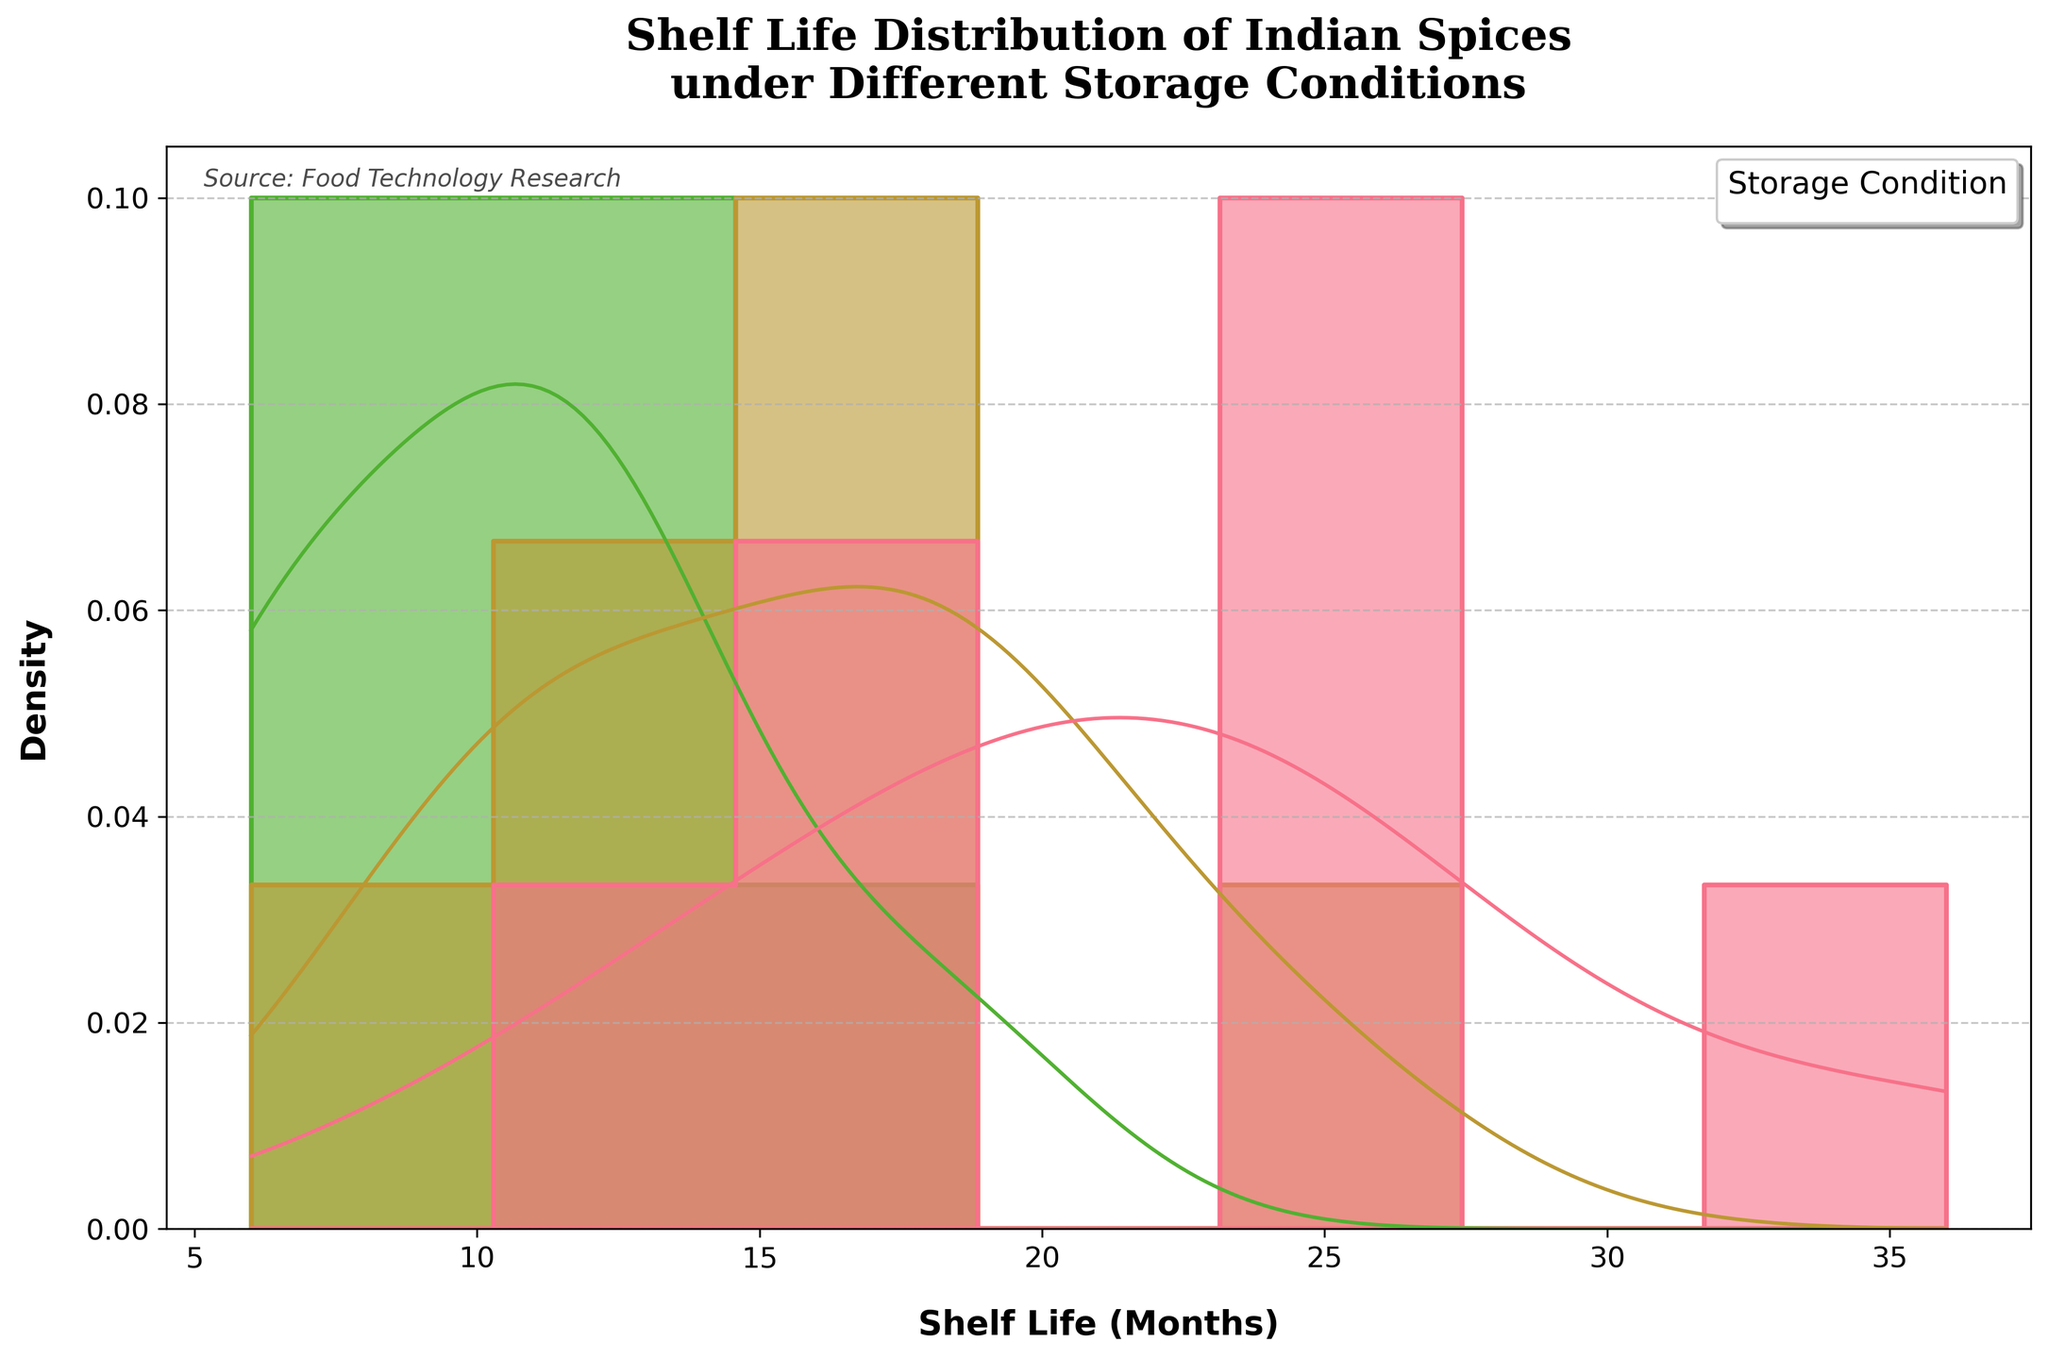what is the title of the plot? The title of the plot is usually displayed at the top center of the figure in large bold text. In this case, it reads 'Shelf Life Distribution of Indian Spices under Different Storage Conditions'.
Answer: Shelf Life Distribution of Indian Spices under Different Storage Conditions What is plotted on the x-axis, and what are the units? The x-axis represents the 'Shelf Life (Months)', which indicates the number of months the spices can be stored under different conditions.
Answer: Shelf Life (Months) Which storage condition shows the highest density for shelf life at around 24 months? To find the storage condition with the highest density around 24 months, we look at the KDE (density curve) peaks near 24 months. The Cool_Dry condition shows the highest peak around 24 months.
Answer: Cool_Dry Which spice has the shortest shelf life under Warm_Humid conditions? To determine the spice with the shortest shelf life under Warm_Humid conditions, we inspect the histogram bars corresponding to 6 months and find that Cardamom has this value.
Answer: Cardamom Does Cool_Dry storage condition consistently show higher shelf life compared to Room_Temperature and Warm_Humid conditions? To answer this, we observe the KDE (density curves) and histogram bars for Cool_Dry (usually in different colors) and see they tend to show higher shelf life months consistently compared to those for Room_Temperature and Warm_Humid.
Answer: Yes Which storage condition typically results in the lowest shelf life and by how much on average? Analyze the KDE density curves and histogram bars for elements like lowest peaks and shortest x-axis intervals. The Warm_Humid condition has the lowest shelf life, averaging around 9-12 months across different spices.
Answer: Warm_Humid by around 9-12 months On average, how much longer is the shelf life under Cool_Dry compared to Warm_Humid conditions? Calculate the average shelf life for spices under Cool_Dry and Warm_Humid conditions (e.g., taking 24, 18, 12 months for Cool_Dry and 12, 9, 6 months for Warm_Humid, respectively) and then compute the difference.
Answer: About 9-12 months What is the median shelf life for spices stored under Room_Temperature? To find the median shelf life, look at the histogram and KDE lines for the Room_Temperature condition. The median value separates the higher half from the lower half. This is generally around 18 months for Room_Temperature.
Answer: 18 months Which spice shows the largest variation in shelf life across different storage conditions? Identify the spice with the widest range between the lowest and highest shelf life values across conditions by examining the histogram bars for each spice. Black_Pepper ranges from 18 months to 36 months.
Answer: Black_Pepper What does a higher peak in the KDE curve indicate? A higher peak in the KDE curve indicates a higher density and thus a larger number of spices having that particular shelf life value.
Answer: Higher density/number 